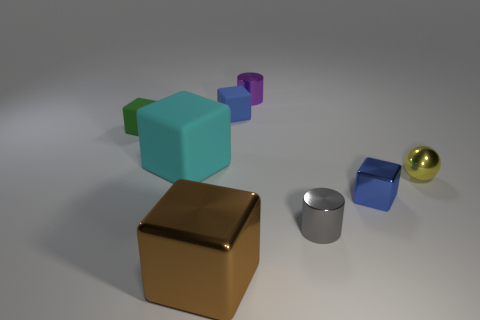Subtract all blue cubes. How many were subtracted if there are1blue cubes left? 1 Add 2 metal cubes. How many objects exist? 10 Subtract all green blocks. How many blocks are left? 4 Subtract all tiny matte blocks. How many blocks are left? 3 Subtract all purple blocks. Subtract all blue cylinders. How many blocks are left? 5 Subtract all balls. How many objects are left? 7 Add 6 large purple cylinders. How many large purple cylinders exist? 6 Subtract 0 purple spheres. How many objects are left? 8 Subtract all cyan cylinders. Subtract all cyan cubes. How many objects are left? 7 Add 2 cyan objects. How many cyan objects are left? 3 